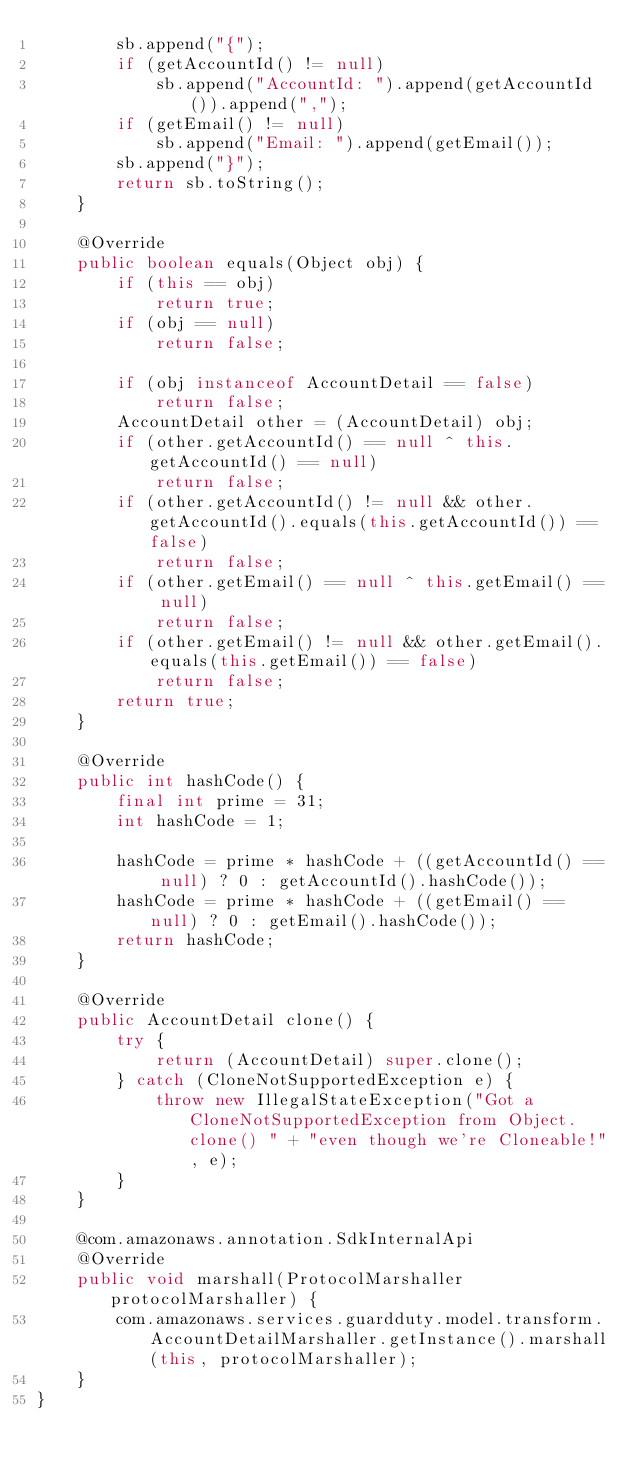<code> <loc_0><loc_0><loc_500><loc_500><_Java_>        sb.append("{");
        if (getAccountId() != null)
            sb.append("AccountId: ").append(getAccountId()).append(",");
        if (getEmail() != null)
            sb.append("Email: ").append(getEmail());
        sb.append("}");
        return sb.toString();
    }

    @Override
    public boolean equals(Object obj) {
        if (this == obj)
            return true;
        if (obj == null)
            return false;

        if (obj instanceof AccountDetail == false)
            return false;
        AccountDetail other = (AccountDetail) obj;
        if (other.getAccountId() == null ^ this.getAccountId() == null)
            return false;
        if (other.getAccountId() != null && other.getAccountId().equals(this.getAccountId()) == false)
            return false;
        if (other.getEmail() == null ^ this.getEmail() == null)
            return false;
        if (other.getEmail() != null && other.getEmail().equals(this.getEmail()) == false)
            return false;
        return true;
    }

    @Override
    public int hashCode() {
        final int prime = 31;
        int hashCode = 1;

        hashCode = prime * hashCode + ((getAccountId() == null) ? 0 : getAccountId().hashCode());
        hashCode = prime * hashCode + ((getEmail() == null) ? 0 : getEmail().hashCode());
        return hashCode;
    }

    @Override
    public AccountDetail clone() {
        try {
            return (AccountDetail) super.clone();
        } catch (CloneNotSupportedException e) {
            throw new IllegalStateException("Got a CloneNotSupportedException from Object.clone() " + "even though we're Cloneable!", e);
        }
    }

    @com.amazonaws.annotation.SdkInternalApi
    @Override
    public void marshall(ProtocolMarshaller protocolMarshaller) {
        com.amazonaws.services.guardduty.model.transform.AccountDetailMarshaller.getInstance().marshall(this, protocolMarshaller);
    }
}
</code> 